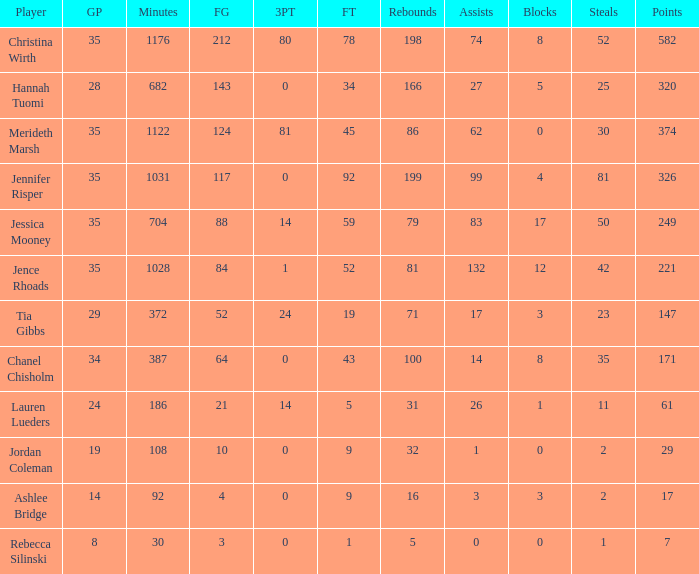How many minutes did chanel chisholm participate in? 1.0. 